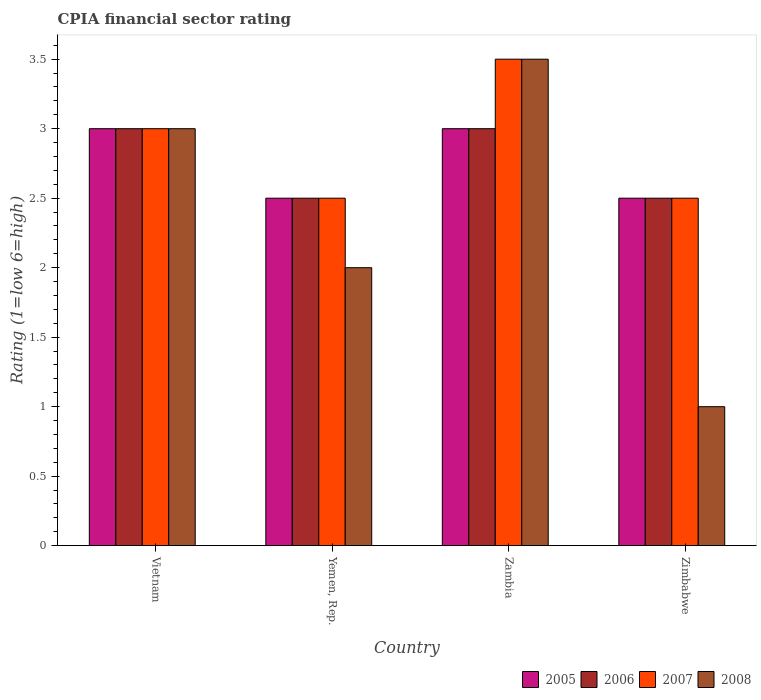How many different coloured bars are there?
Your answer should be very brief. 4. How many bars are there on the 4th tick from the left?
Provide a succinct answer. 4. How many bars are there on the 1st tick from the right?
Make the answer very short. 4. What is the label of the 3rd group of bars from the left?
Your answer should be very brief. Zambia. What is the CPIA rating in 2007 in Vietnam?
Your answer should be compact. 3. Across all countries, what is the maximum CPIA rating in 2008?
Offer a very short reply. 3.5. In which country was the CPIA rating in 2005 maximum?
Offer a very short reply. Vietnam. In which country was the CPIA rating in 2006 minimum?
Offer a very short reply. Yemen, Rep. What is the total CPIA rating in 2007 in the graph?
Offer a very short reply. 11.5. What is the difference between the CPIA rating in 2005 in Vietnam and that in Yemen, Rep.?
Your answer should be compact. 0.5. What is the average CPIA rating in 2006 per country?
Give a very brief answer. 2.75. What is the difference between the CPIA rating of/in 2007 and CPIA rating of/in 2005 in Vietnam?
Keep it short and to the point. 0. In how many countries, is the CPIA rating in 2007 greater than 3.3?
Give a very brief answer. 1. What is the ratio of the CPIA rating in 2007 in Yemen, Rep. to that in Zambia?
Keep it short and to the point. 0.71. Is the difference between the CPIA rating in 2007 in Vietnam and Yemen, Rep. greater than the difference between the CPIA rating in 2005 in Vietnam and Yemen, Rep.?
Your response must be concise. No. What is the difference between the highest and the second highest CPIA rating in 2005?
Ensure brevity in your answer.  -0.5. In how many countries, is the CPIA rating in 2006 greater than the average CPIA rating in 2006 taken over all countries?
Your answer should be compact. 2. Is it the case that in every country, the sum of the CPIA rating in 2008 and CPIA rating in 2005 is greater than the sum of CPIA rating in 2006 and CPIA rating in 2007?
Your answer should be very brief. No. What does the 2nd bar from the left in Zambia represents?
Provide a succinct answer. 2006. What does the 2nd bar from the right in Vietnam represents?
Keep it short and to the point. 2007. How many bars are there?
Offer a terse response. 16. Are all the bars in the graph horizontal?
Offer a terse response. No. How many countries are there in the graph?
Ensure brevity in your answer.  4. Does the graph contain grids?
Provide a succinct answer. No. Where does the legend appear in the graph?
Offer a terse response. Bottom right. How are the legend labels stacked?
Your answer should be very brief. Horizontal. What is the title of the graph?
Give a very brief answer. CPIA financial sector rating. What is the label or title of the X-axis?
Offer a terse response. Country. What is the Rating (1=low 6=high) in 2005 in Yemen, Rep.?
Make the answer very short. 2.5. What is the Rating (1=low 6=high) in 2007 in Yemen, Rep.?
Your answer should be very brief. 2.5. What is the Rating (1=low 6=high) of 2006 in Zambia?
Make the answer very short. 3. What is the Rating (1=low 6=high) in 2008 in Zambia?
Your response must be concise. 3.5. What is the Rating (1=low 6=high) in 2007 in Zimbabwe?
Offer a terse response. 2.5. What is the Rating (1=low 6=high) in 2008 in Zimbabwe?
Ensure brevity in your answer.  1. Across all countries, what is the maximum Rating (1=low 6=high) of 2006?
Offer a terse response. 3. Across all countries, what is the maximum Rating (1=low 6=high) of 2007?
Offer a terse response. 3.5. Across all countries, what is the minimum Rating (1=low 6=high) in 2006?
Your response must be concise. 2.5. Across all countries, what is the minimum Rating (1=low 6=high) in 2007?
Make the answer very short. 2.5. What is the total Rating (1=low 6=high) in 2006 in the graph?
Your response must be concise. 11. What is the difference between the Rating (1=low 6=high) in 2006 in Vietnam and that in Yemen, Rep.?
Provide a succinct answer. 0.5. What is the difference between the Rating (1=low 6=high) of 2005 in Vietnam and that in Zambia?
Your answer should be compact. 0. What is the difference between the Rating (1=low 6=high) in 2006 in Vietnam and that in Zambia?
Provide a short and direct response. 0. What is the difference between the Rating (1=low 6=high) in 2005 in Vietnam and that in Zimbabwe?
Ensure brevity in your answer.  0.5. What is the difference between the Rating (1=low 6=high) of 2006 in Vietnam and that in Zimbabwe?
Make the answer very short. 0.5. What is the difference between the Rating (1=low 6=high) in 2007 in Vietnam and that in Zimbabwe?
Offer a very short reply. 0.5. What is the difference between the Rating (1=low 6=high) of 2006 in Yemen, Rep. and that in Zambia?
Provide a succinct answer. -0.5. What is the difference between the Rating (1=low 6=high) of 2007 in Yemen, Rep. and that in Zambia?
Offer a terse response. -1. What is the difference between the Rating (1=low 6=high) in 2008 in Yemen, Rep. and that in Zambia?
Offer a very short reply. -1.5. What is the difference between the Rating (1=low 6=high) of 2005 in Yemen, Rep. and that in Zimbabwe?
Provide a succinct answer. 0. What is the difference between the Rating (1=low 6=high) in 2008 in Yemen, Rep. and that in Zimbabwe?
Your answer should be compact. 1. What is the difference between the Rating (1=low 6=high) of 2005 in Zambia and that in Zimbabwe?
Make the answer very short. 0.5. What is the difference between the Rating (1=low 6=high) of 2006 in Zambia and that in Zimbabwe?
Ensure brevity in your answer.  0.5. What is the difference between the Rating (1=low 6=high) in 2007 in Zambia and that in Zimbabwe?
Provide a succinct answer. 1. What is the difference between the Rating (1=low 6=high) of 2005 in Vietnam and the Rating (1=low 6=high) of 2007 in Yemen, Rep.?
Provide a succinct answer. 0.5. What is the difference between the Rating (1=low 6=high) of 2007 in Vietnam and the Rating (1=low 6=high) of 2008 in Yemen, Rep.?
Provide a short and direct response. 1. What is the difference between the Rating (1=low 6=high) of 2005 in Vietnam and the Rating (1=low 6=high) of 2008 in Zambia?
Your answer should be very brief. -0.5. What is the difference between the Rating (1=low 6=high) of 2006 in Vietnam and the Rating (1=low 6=high) of 2007 in Zambia?
Provide a short and direct response. -0.5. What is the difference between the Rating (1=low 6=high) in 2007 in Vietnam and the Rating (1=low 6=high) in 2008 in Zambia?
Your answer should be very brief. -0.5. What is the difference between the Rating (1=low 6=high) of 2005 in Vietnam and the Rating (1=low 6=high) of 2006 in Zimbabwe?
Your answer should be compact. 0.5. What is the difference between the Rating (1=low 6=high) in 2006 in Vietnam and the Rating (1=low 6=high) in 2007 in Zimbabwe?
Make the answer very short. 0.5. What is the difference between the Rating (1=low 6=high) in 2007 in Vietnam and the Rating (1=low 6=high) in 2008 in Zimbabwe?
Your response must be concise. 2. What is the difference between the Rating (1=low 6=high) in 2005 in Yemen, Rep. and the Rating (1=low 6=high) in 2006 in Zambia?
Provide a short and direct response. -0.5. What is the difference between the Rating (1=low 6=high) of 2006 in Yemen, Rep. and the Rating (1=low 6=high) of 2007 in Zambia?
Provide a succinct answer. -1. What is the difference between the Rating (1=low 6=high) of 2006 in Yemen, Rep. and the Rating (1=low 6=high) of 2008 in Zambia?
Your answer should be compact. -1. What is the difference between the Rating (1=low 6=high) in 2007 in Yemen, Rep. and the Rating (1=low 6=high) in 2008 in Zambia?
Your answer should be compact. -1. What is the difference between the Rating (1=low 6=high) of 2005 in Yemen, Rep. and the Rating (1=low 6=high) of 2006 in Zimbabwe?
Provide a short and direct response. 0. What is the difference between the Rating (1=low 6=high) of 2005 in Yemen, Rep. and the Rating (1=low 6=high) of 2008 in Zimbabwe?
Keep it short and to the point. 1.5. What is the difference between the Rating (1=low 6=high) of 2006 in Yemen, Rep. and the Rating (1=low 6=high) of 2008 in Zimbabwe?
Ensure brevity in your answer.  1.5. What is the difference between the Rating (1=low 6=high) in 2007 in Yemen, Rep. and the Rating (1=low 6=high) in 2008 in Zimbabwe?
Keep it short and to the point. 1.5. What is the difference between the Rating (1=low 6=high) of 2005 in Zambia and the Rating (1=low 6=high) of 2006 in Zimbabwe?
Offer a terse response. 0.5. What is the difference between the Rating (1=low 6=high) in 2005 in Zambia and the Rating (1=low 6=high) in 2008 in Zimbabwe?
Offer a terse response. 2. What is the difference between the Rating (1=low 6=high) in 2006 in Zambia and the Rating (1=low 6=high) in 2007 in Zimbabwe?
Your response must be concise. 0.5. What is the average Rating (1=low 6=high) of 2005 per country?
Provide a short and direct response. 2.75. What is the average Rating (1=low 6=high) of 2006 per country?
Your response must be concise. 2.75. What is the average Rating (1=low 6=high) of 2007 per country?
Give a very brief answer. 2.88. What is the average Rating (1=low 6=high) of 2008 per country?
Offer a terse response. 2.38. What is the difference between the Rating (1=low 6=high) of 2007 and Rating (1=low 6=high) of 2008 in Vietnam?
Give a very brief answer. 0. What is the difference between the Rating (1=low 6=high) of 2005 and Rating (1=low 6=high) of 2008 in Yemen, Rep.?
Give a very brief answer. 0.5. What is the difference between the Rating (1=low 6=high) in 2006 and Rating (1=low 6=high) in 2008 in Yemen, Rep.?
Your answer should be compact. 0.5. What is the difference between the Rating (1=low 6=high) in 2007 and Rating (1=low 6=high) in 2008 in Yemen, Rep.?
Provide a succinct answer. 0.5. What is the difference between the Rating (1=low 6=high) in 2005 and Rating (1=low 6=high) in 2006 in Zambia?
Make the answer very short. 0. What is the difference between the Rating (1=low 6=high) of 2005 and Rating (1=low 6=high) of 2008 in Zambia?
Provide a succinct answer. -0.5. What is the difference between the Rating (1=low 6=high) of 2006 and Rating (1=low 6=high) of 2007 in Zambia?
Keep it short and to the point. -0.5. What is the difference between the Rating (1=low 6=high) of 2006 and Rating (1=low 6=high) of 2008 in Zambia?
Give a very brief answer. -0.5. What is the difference between the Rating (1=low 6=high) of 2007 and Rating (1=low 6=high) of 2008 in Zambia?
Your answer should be very brief. 0. What is the difference between the Rating (1=low 6=high) of 2005 and Rating (1=low 6=high) of 2007 in Zimbabwe?
Make the answer very short. 0. What is the difference between the Rating (1=low 6=high) in 2007 and Rating (1=low 6=high) in 2008 in Zimbabwe?
Provide a succinct answer. 1.5. What is the ratio of the Rating (1=low 6=high) in 2007 in Vietnam to that in Yemen, Rep.?
Provide a short and direct response. 1.2. What is the ratio of the Rating (1=low 6=high) in 2005 in Vietnam to that in Zambia?
Offer a very short reply. 1. What is the ratio of the Rating (1=low 6=high) of 2006 in Vietnam to that in Zambia?
Keep it short and to the point. 1. What is the ratio of the Rating (1=low 6=high) in 2007 in Vietnam to that in Zambia?
Make the answer very short. 0.86. What is the ratio of the Rating (1=low 6=high) in 2007 in Vietnam to that in Zimbabwe?
Provide a short and direct response. 1.2. What is the ratio of the Rating (1=low 6=high) of 2008 in Vietnam to that in Zimbabwe?
Offer a very short reply. 3. What is the ratio of the Rating (1=low 6=high) in 2008 in Yemen, Rep. to that in Zambia?
Make the answer very short. 0.57. What is the ratio of the Rating (1=low 6=high) in 2006 in Yemen, Rep. to that in Zimbabwe?
Make the answer very short. 1. What is the ratio of the Rating (1=low 6=high) in 2007 in Yemen, Rep. to that in Zimbabwe?
Give a very brief answer. 1. What is the ratio of the Rating (1=low 6=high) in 2008 in Yemen, Rep. to that in Zimbabwe?
Your response must be concise. 2. What is the ratio of the Rating (1=low 6=high) in 2007 in Zambia to that in Zimbabwe?
Provide a short and direct response. 1.4. What is the ratio of the Rating (1=low 6=high) of 2008 in Zambia to that in Zimbabwe?
Make the answer very short. 3.5. What is the difference between the highest and the second highest Rating (1=low 6=high) of 2007?
Your answer should be very brief. 0.5. What is the difference between the highest and the second highest Rating (1=low 6=high) in 2008?
Make the answer very short. 0.5. What is the difference between the highest and the lowest Rating (1=low 6=high) of 2006?
Provide a succinct answer. 0.5. What is the difference between the highest and the lowest Rating (1=low 6=high) of 2007?
Provide a succinct answer. 1. What is the difference between the highest and the lowest Rating (1=low 6=high) in 2008?
Provide a succinct answer. 2.5. 